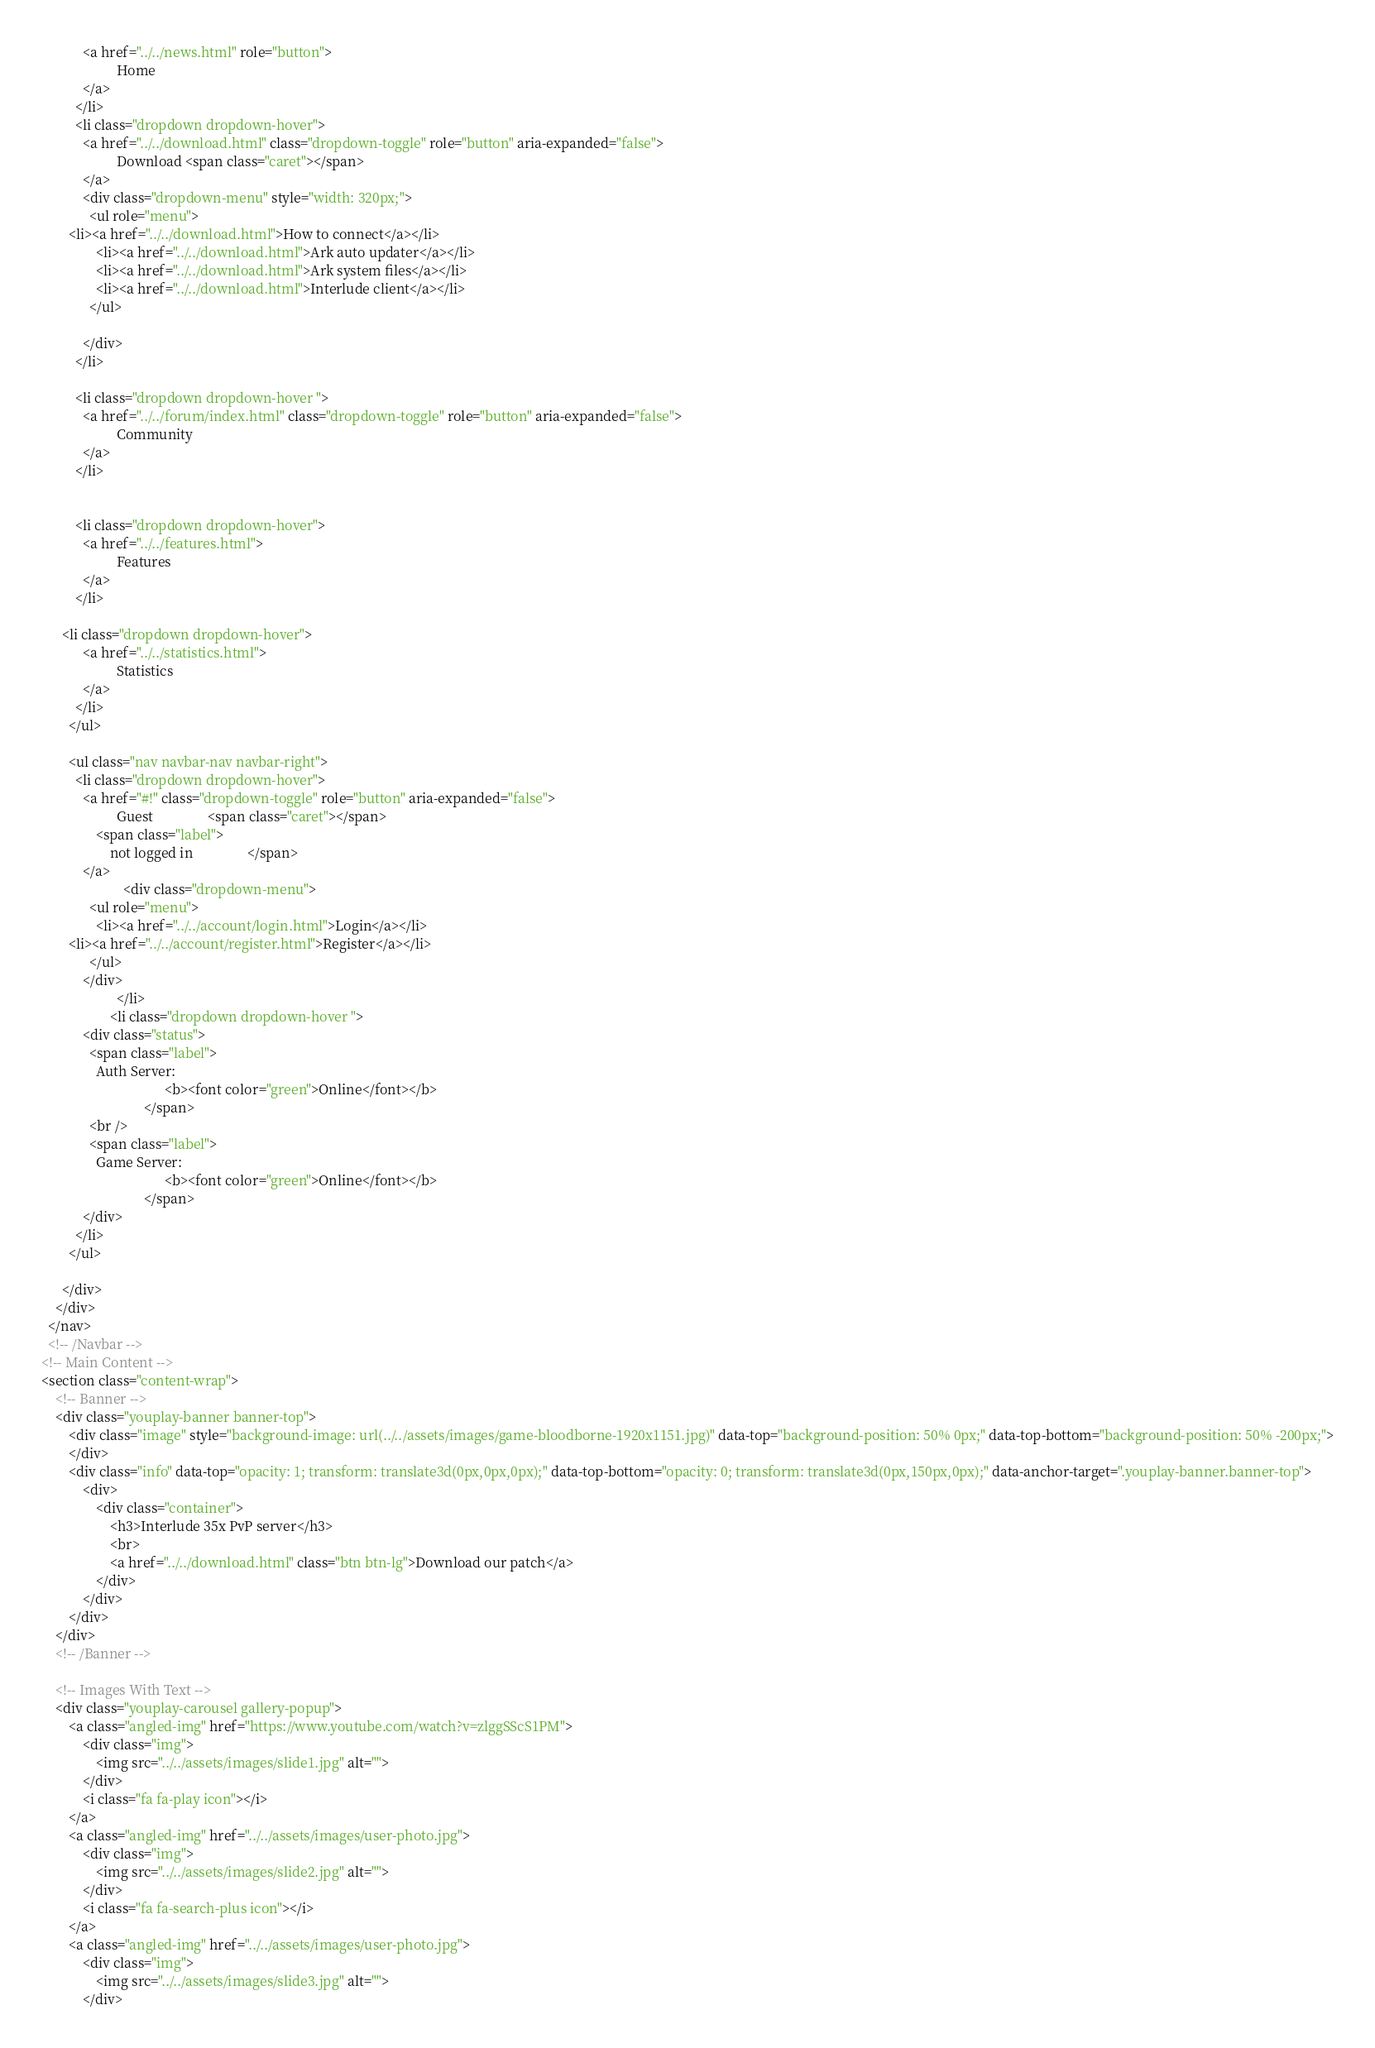Convert code to text. <code><loc_0><loc_0><loc_500><loc_500><_HTML_>            <a href="../../news.html" role="button">
                      Home 
            </a>
          </li>
          <li class="dropdown dropdown-hover">
            <a href="../../download.html" class="dropdown-toggle" role="button" aria-expanded="false">
                      Download <span class="caret"></span>
            </a>
            <div class="dropdown-menu" style="width: 320px;">
              <ul role="menu">
		<li><a href="../../download.html">How to connect</a></li>
                <li><a href="../../download.html">Ark auto updater</a></li>
                <li><a href="../../download.html">Ark system files</a></li>
                <li><a href="../../download.html">Interlude client</a></li>
              </ul>

            </div>
          </li>
		  
          <li class="dropdown dropdown-hover ">
            <a href="../../forum/index.html" class="dropdown-toggle" role="button" aria-expanded="false">
                      Community 
            </a>
          </li>
		  
		  
          <li class="dropdown dropdown-hover">
            <a href="../../features.html">
                      Features 
            </a>
          </li>
		  
	  <li class="dropdown dropdown-hover">
            <a href="../../statistics.html">
                      Statistics 
            </a>
          </li>
        </ul>

        <ul class="nav navbar-nav navbar-right">
          <li class="dropdown dropdown-hover">
            <a href="#!" class="dropdown-toggle" role="button" aria-expanded="false">
                      Guest                <span class="caret"></span>
                <span class="label">
                    not logged in                </span>
            </a>
                        <div class="dropdown-menu">
              <ul role="menu">
                <li><a href="../../account/login.html">Login</a></li>
		<li><a href="../../account/register.html">Register</a></li>
              </ul>
            </div>
                      </li>
                    <li class="dropdown dropdown-hover ">
            <div class="status">
              <span class="label">
                Auth Server:
                                    <b><font color="green">Online</font></b>
                              </span>
              <br />
              <span class="label">
                Game Server:
                                    <b><font color="green">Online</font></b>
                              </span>
            </div>
          </li>
        </ul>
	
      </div>
    </div>
  </nav>
  <!-- /Navbar -->
<!-- Main Content -->
<section class="content-wrap">
    <!-- Banner -->
    <div class="youplay-banner banner-top">
        <div class="image" style="background-image: url(../../assets/images/game-bloodborne-1920x1151.jpg)" data-top="background-position: 50% 0px;" data-top-bottom="background-position: 50% -200px;">
        </div>
        <div class="info" data-top="opacity: 1; transform: translate3d(0px,0px,0px);" data-top-bottom="opacity: 0; transform: translate3d(0px,150px,0px);" data-anchor-target=".youplay-banner.banner-top">
            <div>	
                <div class="container">
                    <h3>Interlude 35x PvP server</h3>
                    <br>
                    <a href="../../download.html" class="btn btn-lg">Download our patch</a>
                </div>
            </div>
        </div>
    </div>
    <!-- /Banner -->

    <!-- Images With Text -->
    <div class="youplay-carousel gallery-popup">
        <a class="angled-img" href="https://www.youtube.com/watch?v=zlggSScS1PM">
            <div class="img">
                <img src="../../assets/images/slide1.jpg" alt="">
            </div>
            <i class="fa fa-play icon"></i>
        </a>
        <a class="angled-img" href="../../assets/images/user-photo.jpg">
            <div class="img">
                <img src="../../assets/images/slide2.jpg" alt="">
            </div>
            <i class="fa fa-search-plus icon"></i>
        </a>
        <a class="angled-img" href="../../assets/images/user-photo.jpg">
            <div class="img">
                <img src="../../assets/images/slide3.jpg" alt="">
            </div></code> 